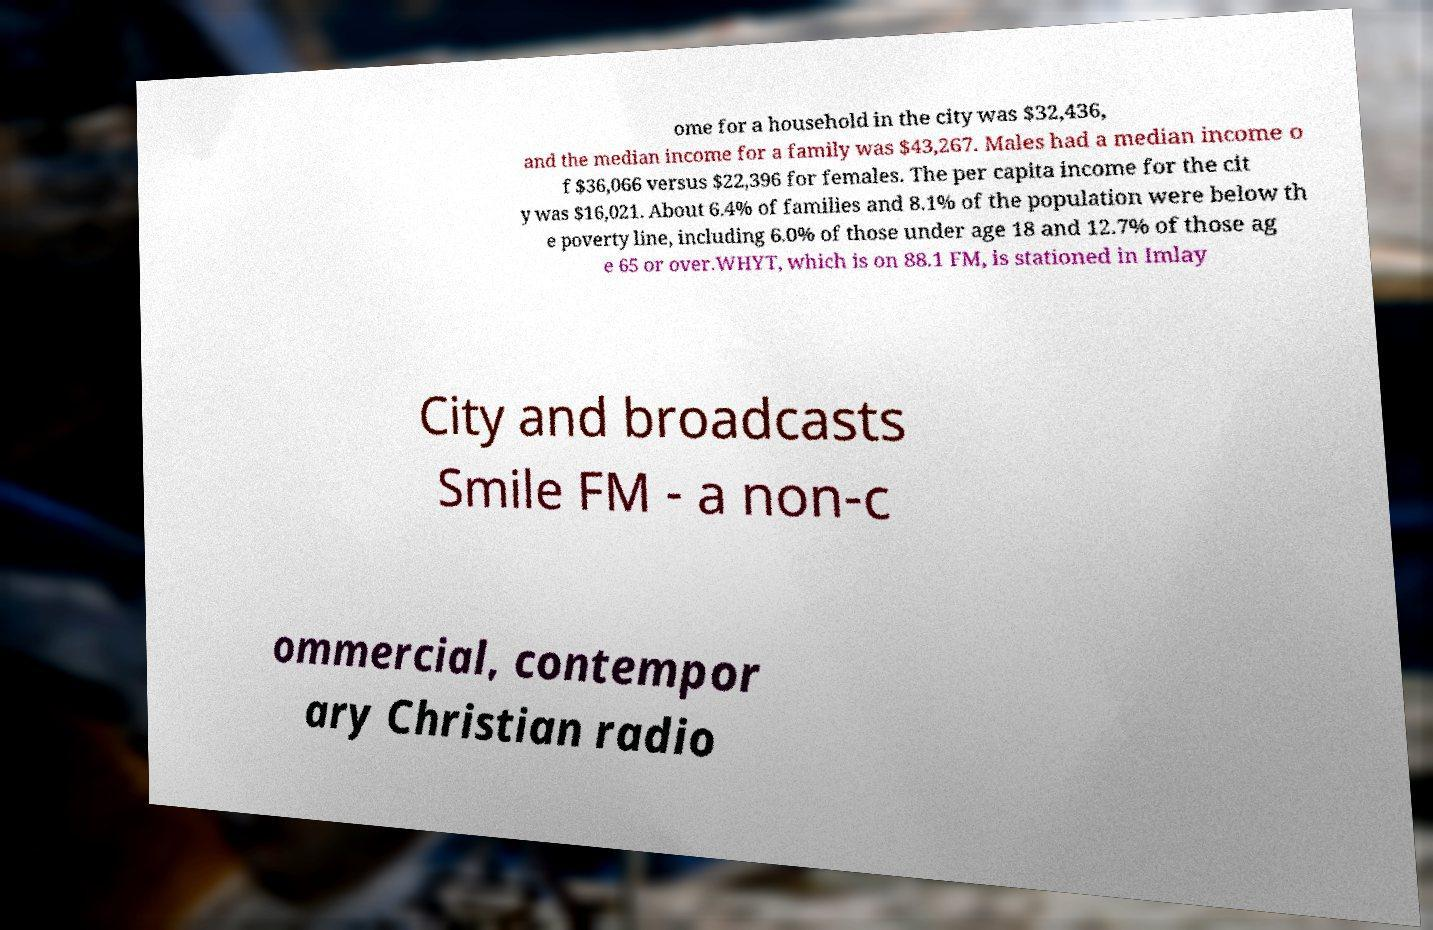I need the written content from this picture converted into text. Can you do that? ome for a household in the city was $32,436, and the median income for a family was $43,267. Males had a median income o f $36,066 versus $22,396 for females. The per capita income for the cit y was $16,021. About 6.4% of families and 8.1% of the population were below th e poverty line, including 6.0% of those under age 18 and 12.7% of those ag e 65 or over.WHYT, which is on 88.1 FM, is stationed in Imlay City and broadcasts Smile FM - a non-c ommercial, contempor ary Christian radio 